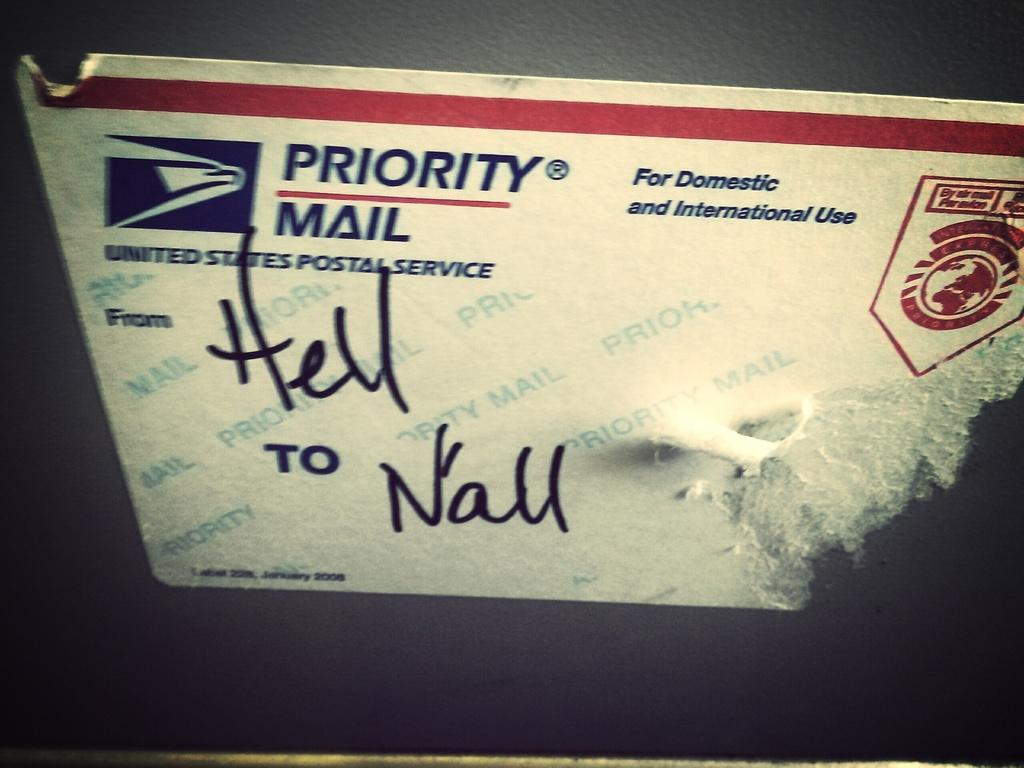What is depicted on the sticker in the image? There is a sticker of a postal service in the image. What information is provided on the sticker? The names of the sender and receiver are mentioned on the sticker. What type of chin can be seen on the development of the carriage in the image? There is no chin, development, or carriage present in the image; it only features a sticker of a postal service with the names of the sender and receiver. 